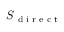Convert formula to latex. <formula><loc_0><loc_0><loc_500><loc_500>S \text  subscript { d i r e c t }</formula> 